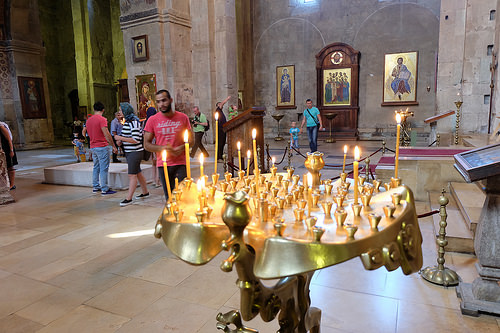<image>
Is there a man in front of the candle stand? No. The man is not in front of the candle stand. The spatial positioning shows a different relationship between these objects. 